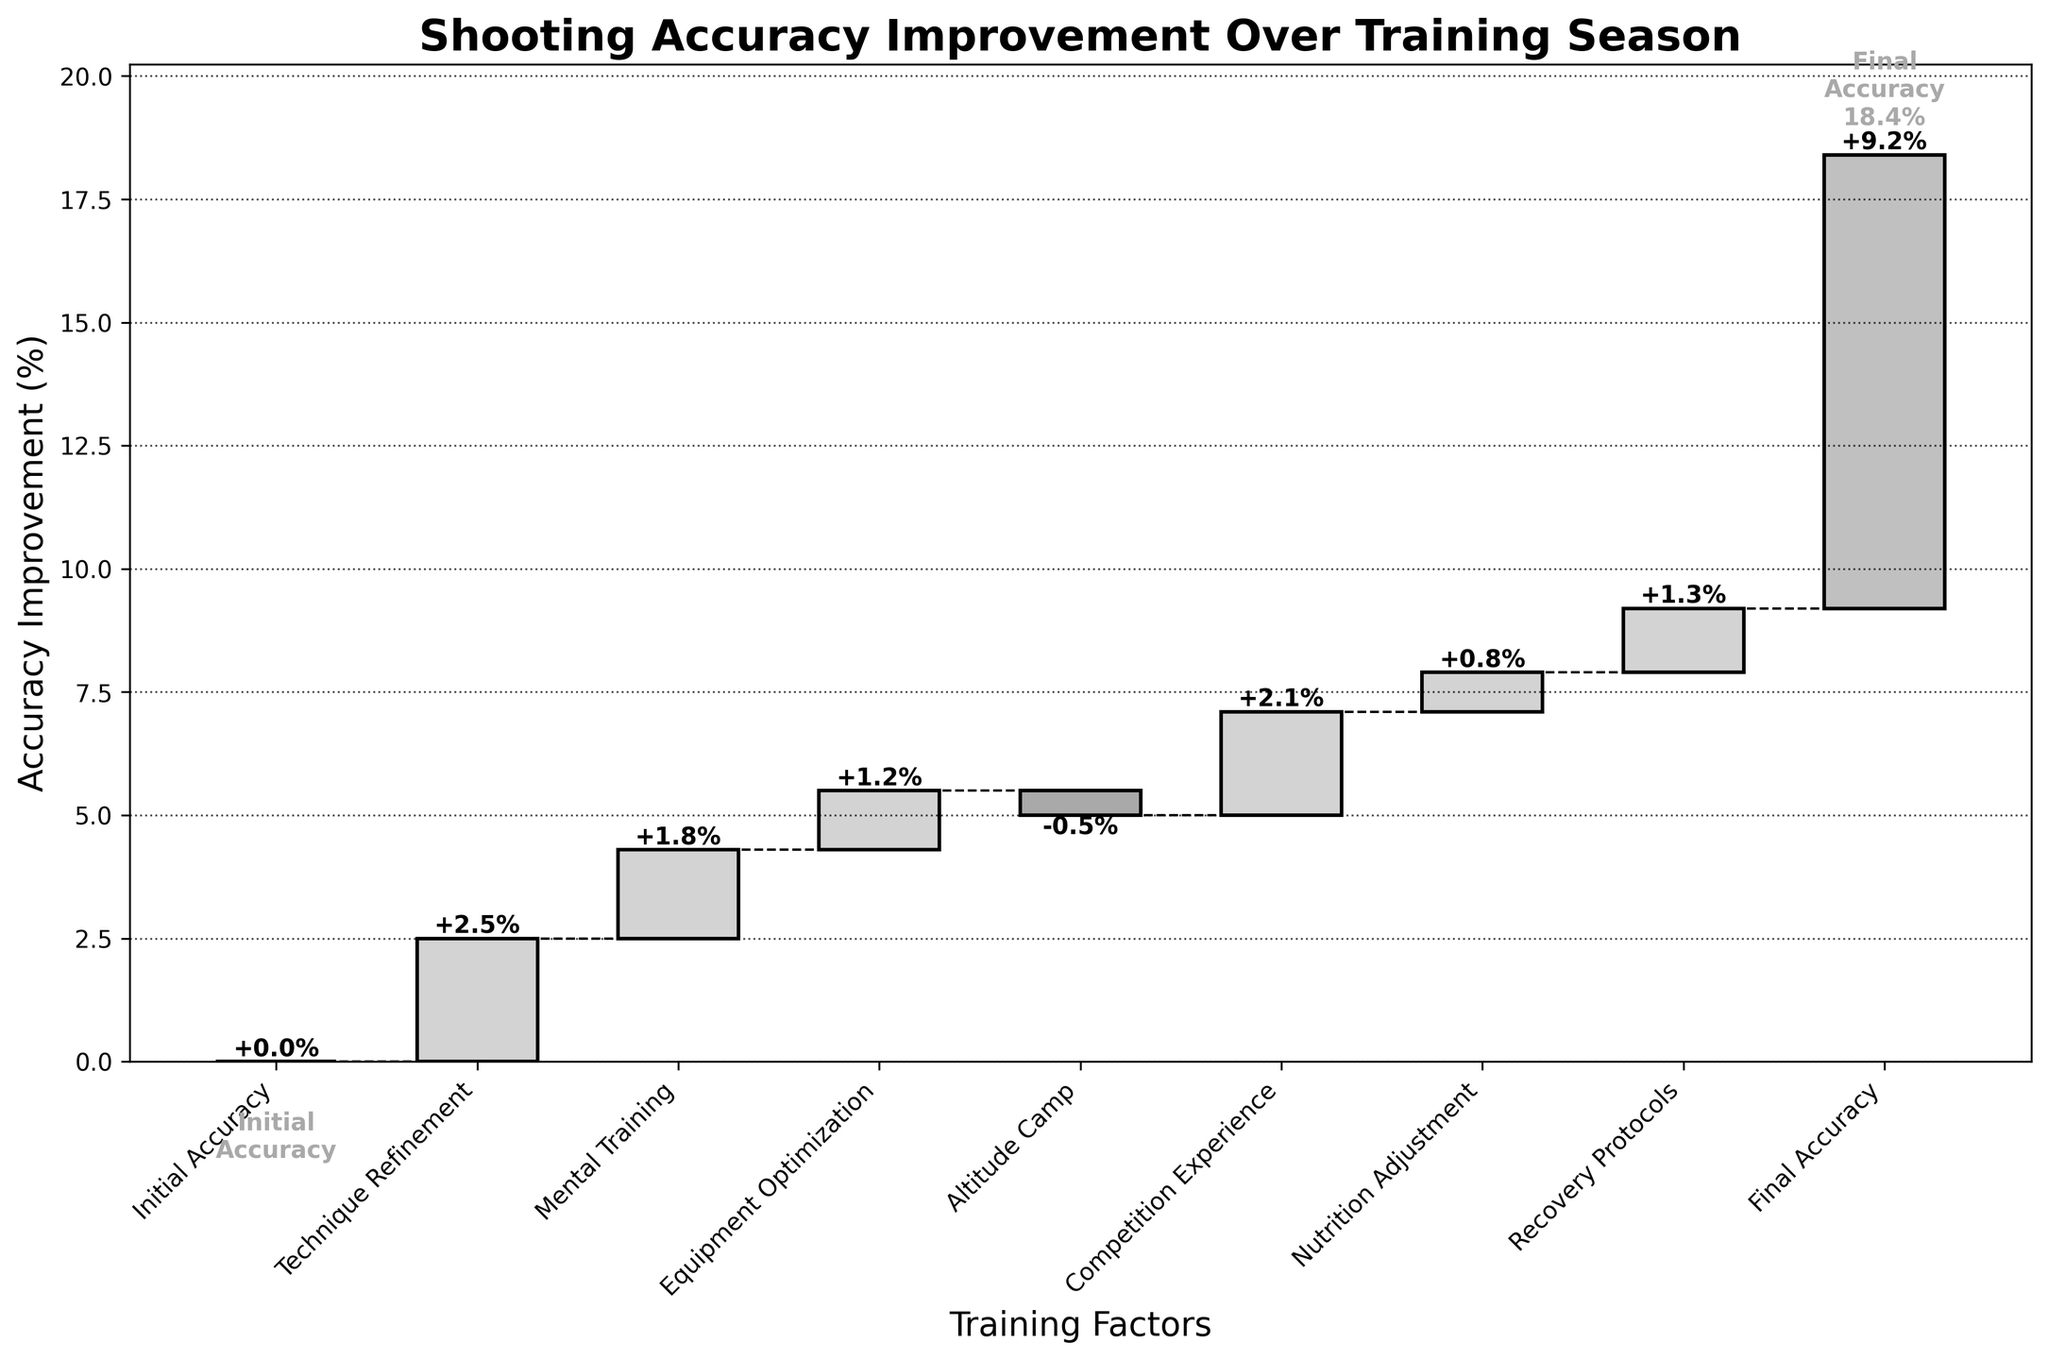What is the title of the figure? The title of the figure can typically be found at the top of most plots, making it clear what the visual is about.
Answer: Shooting Accuracy Improvement Over Training Season How much did Technique Refinement improve accuracy? Locate the "Technique Refinement" bar in the figure and read the value label associated with it.
Answer: 2.5% What is the total improvement in shooting accuracy by the end of the training season? Look at the cumulative value at the last bar labeled "Final Accuracy" for the total improvement.
Answer: 9.2% How did Altitude Camp affect shooting accuracy? Find the bar corresponding to "Altitude Camp" and observe the value change, noting if it is positive or negative.
Answer: -0.5% What is the combined impact of Mental Training and Equipment Optimization? Sum the values for "Mental Training" and "Equipment Optimization," which are 1.8 and 1.2, respectively.
Answer: 3.0% Which training factor contributed the most to accuracy improvement? Compare the value labels of each training factor to determine the largest positive value.
Answer: Technique Refinement What was the effect of Recovery Protocols on accuracy? Identify the bar for "Recovery Protocols" and note the value indicated.
Answer: 1.3% By how much did Competition Experience improve accuracy compared to Nutrition Adjustment? Subtract the value of "Nutrition Adjustment" from "Competition Experience" (2.1 - 0.8).
Answer: 1.3% How many training factors led to a positive impact on accuracy? Count the number of bars with positive values.
Answer: 7 Did any training factor decrease the shooting accuracy? If so, which one? Look for any bar with a negative value and identify the training factor.
Answer: Altitude Camp 